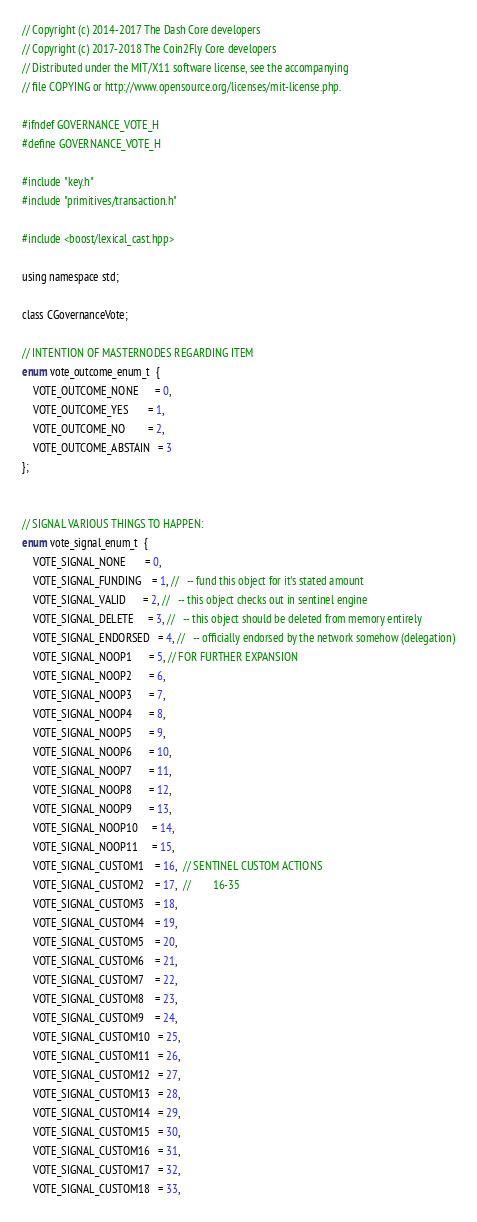<code> <loc_0><loc_0><loc_500><loc_500><_C_>// Copyright (c) 2014-2017 The Dash Core developers
// Copyright (c) 2017-2018 The Coin2Fly Core developers
// Distributed under the MIT/X11 software license, see the accompanying
// file COPYING or http://www.opensource.org/licenses/mit-license.php.

#ifndef GOVERNANCE_VOTE_H
#define GOVERNANCE_VOTE_H

#include "key.h"
#include "primitives/transaction.h"

#include <boost/lexical_cast.hpp>

using namespace std;

class CGovernanceVote;

// INTENTION OF MASTERNODES REGARDING ITEM
enum vote_outcome_enum_t  {
    VOTE_OUTCOME_NONE      = 0,
    VOTE_OUTCOME_YES       = 1,
    VOTE_OUTCOME_NO        = 2,
    VOTE_OUTCOME_ABSTAIN   = 3
};


// SIGNAL VARIOUS THINGS TO HAPPEN:
enum vote_signal_enum_t  {
    VOTE_SIGNAL_NONE       = 0,
    VOTE_SIGNAL_FUNDING    = 1, //   -- fund this object for it's stated amount
    VOTE_SIGNAL_VALID      = 2, //   -- this object checks out in sentinel engine
    VOTE_SIGNAL_DELETE     = 3, //   -- this object should be deleted from memory entirely
    VOTE_SIGNAL_ENDORSED   = 4, //   -- officially endorsed by the network somehow (delegation)
    VOTE_SIGNAL_NOOP1      = 5, // FOR FURTHER EXPANSION
    VOTE_SIGNAL_NOOP2      = 6,
    VOTE_SIGNAL_NOOP3      = 7,
    VOTE_SIGNAL_NOOP4      = 8,
    VOTE_SIGNAL_NOOP5      = 9,
    VOTE_SIGNAL_NOOP6      = 10,
    VOTE_SIGNAL_NOOP7      = 11,
    VOTE_SIGNAL_NOOP8      = 12,
    VOTE_SIGNAL_NOOP9      = 13,
    VOTE_SIGNAL_NOOP10     = 14,
    VOTE_SIGNAL_NOOP11     = 15,
    VOTE_SIGNAL_CUSTOM1    = 16,  // SENTINEL CUSTOM ACTIONS
    VOTE_SIGNAL_CUSTOM2    = 17,  //        16-35
    VOTE_SIGNAL_CUSTOM3    = 18,
    VOTE_SIGNAL_CUSTOM4    = 19,
    VOTE_SIGNAL_CUSTOM5    = 20,
    VOTE_SIGNAL_CUSTOM6    = 21,
    VOTE_SIGNAL_CUSTOM7    = 22,
    VOTE_SIGNAL_CUSTOM8    = 23,
    VOTE_SIGNAL_CUSTOM9    = 24,
    VOTE_SIGNAL_CUSTOM10   = 25,
    VOTE_SIGNAL_CUSTOM11   = 26,
    VOTE_SIGNAL_CUSTOM12   = 27,
    VOTE_SIGNAL_CUSTOM13   = 28,
    VOTE_SIGNAL_CUSTOM14   = 29,
    VOTE_SIGNAL_CUSTOM15   = 30,
    VOTE_SIGNAL_CUSTOM16   = 31,
    VOTE_SIGNAL_CUSTOM17   = 32,
    VOTE_SIGNAL_CUSTOM18   = 33,</code> 